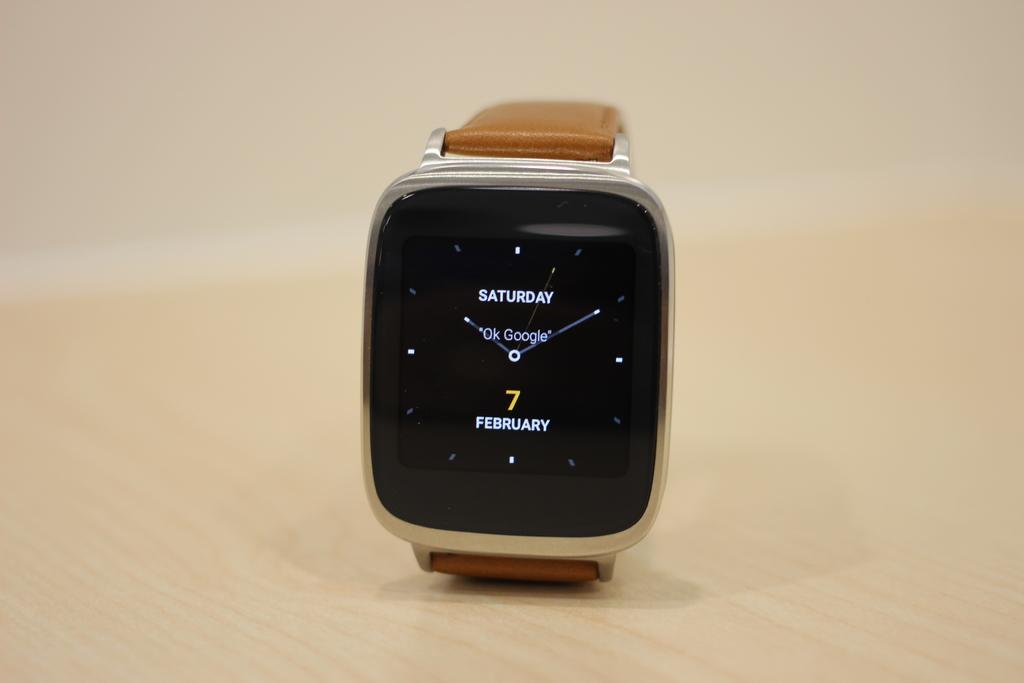<image>
Offer a succinct explanation of the picture presented. Watch facing says SATURDAY Ok Google 7 FEBRUARY 